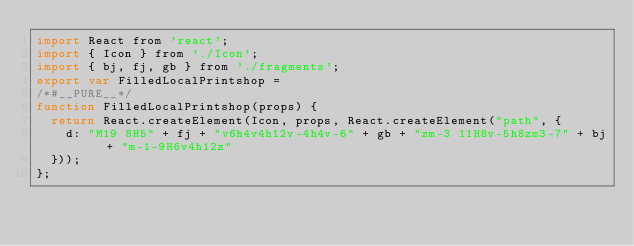Convert code to text. <code><loc_0><loc_0><loc_500><loc_500><_JavaScript_>import React from 'react';
import { Icon } from './Icon';
import { bj, fj, gb } from './fragments';
export var FilledLocalPrintshop =
/*#__PURE__*/
function FilledLocalPrintshop(props) {
  return React.createElement(Icon, props, React.createElement("path", {
    d: "M19 8H5" + fj + "v6h4v4h12v-4h4v-6" + gb + "zm-3 11H8v-5h8zm3-7" + bj + "m-1-9H6v4h12z"
  }));
};</code> 